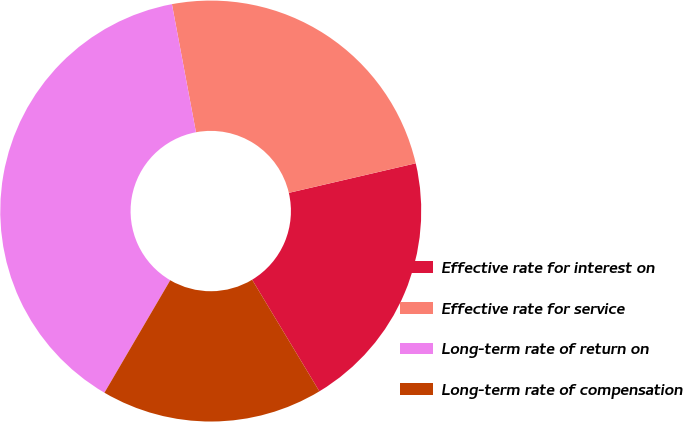Convert chart to OTSL. <chart><loc_0><loc_0><loc_500><loc_500><pie_chart><fcel>Effective rate for interest on<fcel>Effective rate for service<fcel>Long-term rate of return on<fcel>Long-term rate of compensation<nl><fcel>20.01%<fcel>24.31%<fcel>38.62%<fcel>17.06%<nl></chart> 